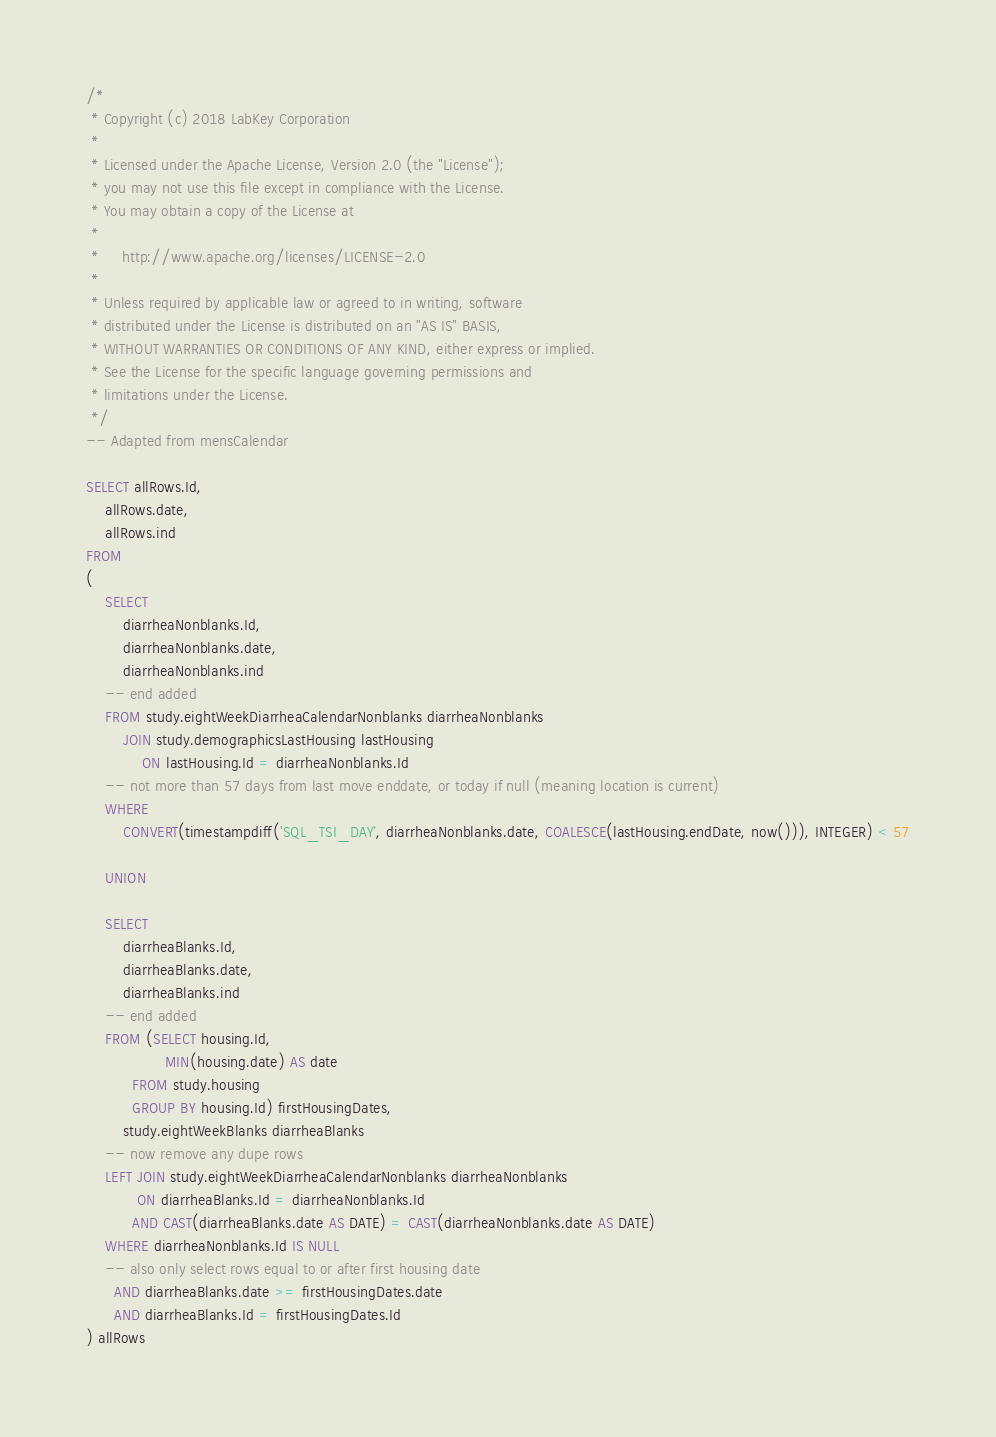Convert code to text. <code><loc_0><loc_0><loc_500><loc_500><_SQL_>/*
 * Copyright (c) 2018 LabKey Corporation
 *
 * Licensed under the Apache License, Version 2.0 (the "License");
 * you may not use this file except in compliance with the License.
 * You may obtain a copy of the License at
 *
 *     http://www.apache.org/licenses/LICENSE-2.0
 *
 * Unless required by applicable law or agreed to in writing, software
 * distributed under the License is distributed on an "AS IS" BASIS,
 * WITHOUT WARRANTIES OR CONDITIONS OF ANY KIND, either express or implied.
 * See the License for the specific language governing permissions and
 * limitations under the License.
 */
-- Adapted from mensCalendar

SELECT allRows.Id,
    allRows.date,
    allRows.ind
FROM
(
    SELECT
        diarrheaNonblanks.Id,
        diarrheaNonblanks.date,
        diarrheaNonblanks.ind
    -- end added
    FROM study.eightWeekDiarrheaCalendarNonblanks diarrheaNonblanks
        JOIN study.demographicsLastHousing lastHousing
            ON lastHousing.Id = diarrheaNonblanks.Id
    -- not more than 57 days from last move enddate, or today if null (meaning location is current)
    WHERE
        CONVERT(timestampdiff('SQL_TSI_DAY', diarrheaNonblanks.date, COALESCE(lastHousing.endDate, now())), INTEGER) < 57

    UNION

    SELECT
        diarrheaBlanks.Id,
        diarrheaBlanks.date,
        diarrheaBlanks.ind
    -- end added
    FROM (SELECT housing.Id,
                 MIN(housing.date) AS date
          FROM study.housing
          GROUP BY housing.Id) firstHousingDates,
        study.eightWeekBlanks diarrheaBlanks
    -- now remove any dupe rows
    LEFT JOIN study.eightWeekDiarrheaCalendarNonblanks diarrheaNonblanks
           ON diarrheaBlanks.Id = diarrheaNonblanks.Id
          AND CAST(diarrheaBlanks.date AS DATE) = CAST(diarrheaNonblanks.date AS DATE)
    WHERE diarrheaNonblanks.Id IS NULL
    -- also only select rows equal to or after first housing date
      AND diarrheaBlanks.date >= firstHousingDates.date
      AND diarrheaBlanks.Id = firstHousingDates.Id
) allRows</code> 